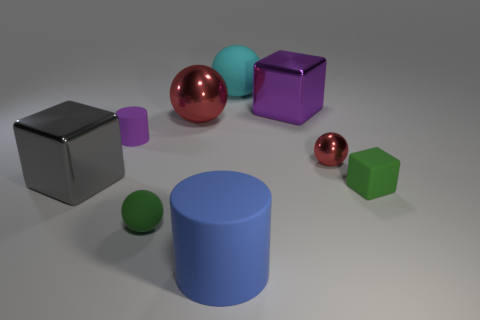Subtract all brown cubes. How many red spheres are left? 2 Subtract all big cyan balls. How many balls are left? 3 Subtract 1 cubes. How many cubes are left? 2 Add 1 tiny purple metallic cubes. How many objects exist? 10 Subtract all green spheres. How many spheres are left? 3 Subtract all small purple things. Subtract all large yellow spheres. How many objects are left? 8 Add 3 small purple objects. How many small purple objects are left? 4 Add 8 small metal cubes. How many small metal cubes exist? 8 Subtract 0 brown spheres. How many objects are left? 9 Subtract all cylinders. How many objects are left? 7 